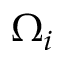<formula> <loc_0><loc_0><loc_500><loc_500>\Omega _ { i }</formula> 